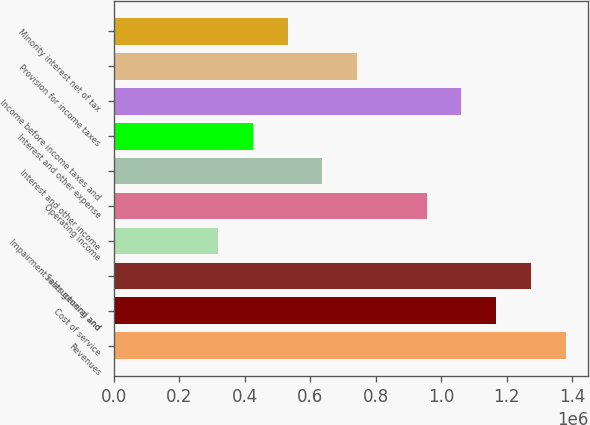Convert chart to OTSL. <chart><loc_0><loc_0><loc_500><loc_500><bar_chart><fcel>Revenues<fcel>Cost of service<fcel>Sales general and<fcel>Impairment restructuring and<fcel>Operating income<fcel>Interest and other income<fcel>Interest and other expense<fcel>Income before income taxes and<fcel>Provision for income taxes<fcel>Minority interest net of tax<nl><fcel>1.37998e+06<fcel>1.16768e+06<fcel>1.27383e+06<fcel>318457<fcel>955371<fcel>636914<fcel>424609<fcel>1.06152e+06<fcel>743066<fcel>530762<nl></chart> 